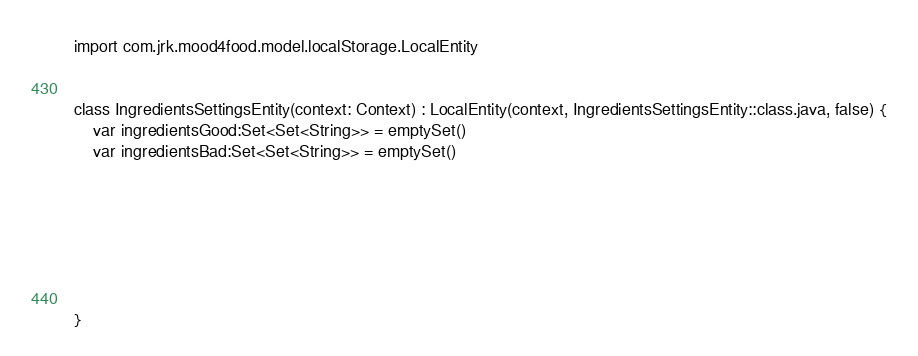Convert code to text. <code><loc_0><loc_0><loc_500><loc_500><_Kotlin_>import com.jrk.mood4food.model.localStorage.LocalEntity


class IngredientsSettingsEntity(context: Context) : LocalEntity(context, IngredientsSettingsEntity::class.java, false) {
    var ingredientsGood:Set<Set<String>> = emptySet()
    var ingredientsBad:Set<Set<String>> = emptySet()







}</code> 